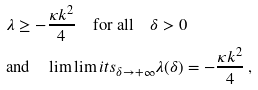Convert formula to latex. <formula><loc_0><loc_0><loc_500><loc_500>& \lambda \geq - \frac { \kappa k ^ { 2 } } { 4 } \quad \text {for all} \quad \delta > 0 \\ & \text {and} \quad \lim \lim i t s _ { \delta \rightarrow + \infty } \lambda ( \delta ) = - \frac { \kappa k ^ { 2 } } { 4 } \, ,</formula> 